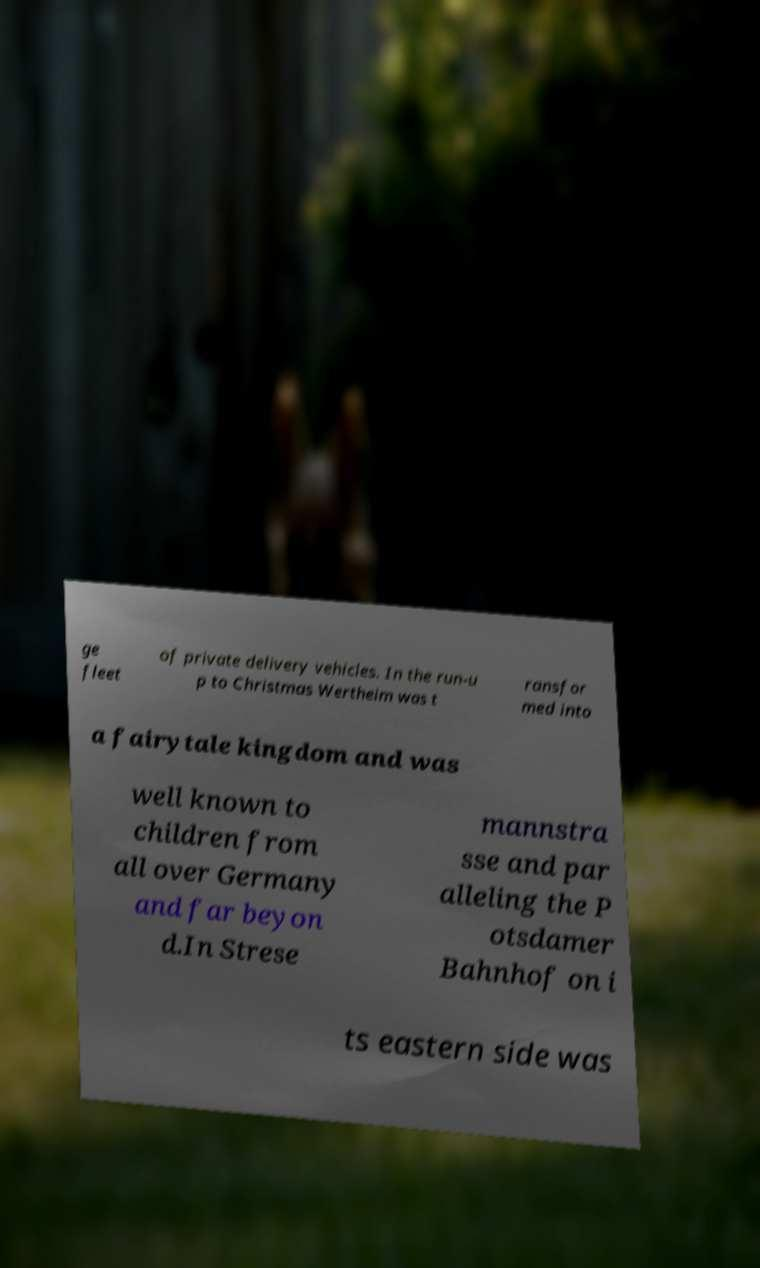For documentation purposes, I need the text within this image transcribed. Could you provide that? ge fleet of private delivery vehicles. In the run-u p to Christmas Wertheim was t ransfor med into a fairytale kingdom and was well known to children from all over Germany and far beyon d.In Strese mannstra sse and par alleling the P otsdamer Bahnhof on i ts eastern side was 